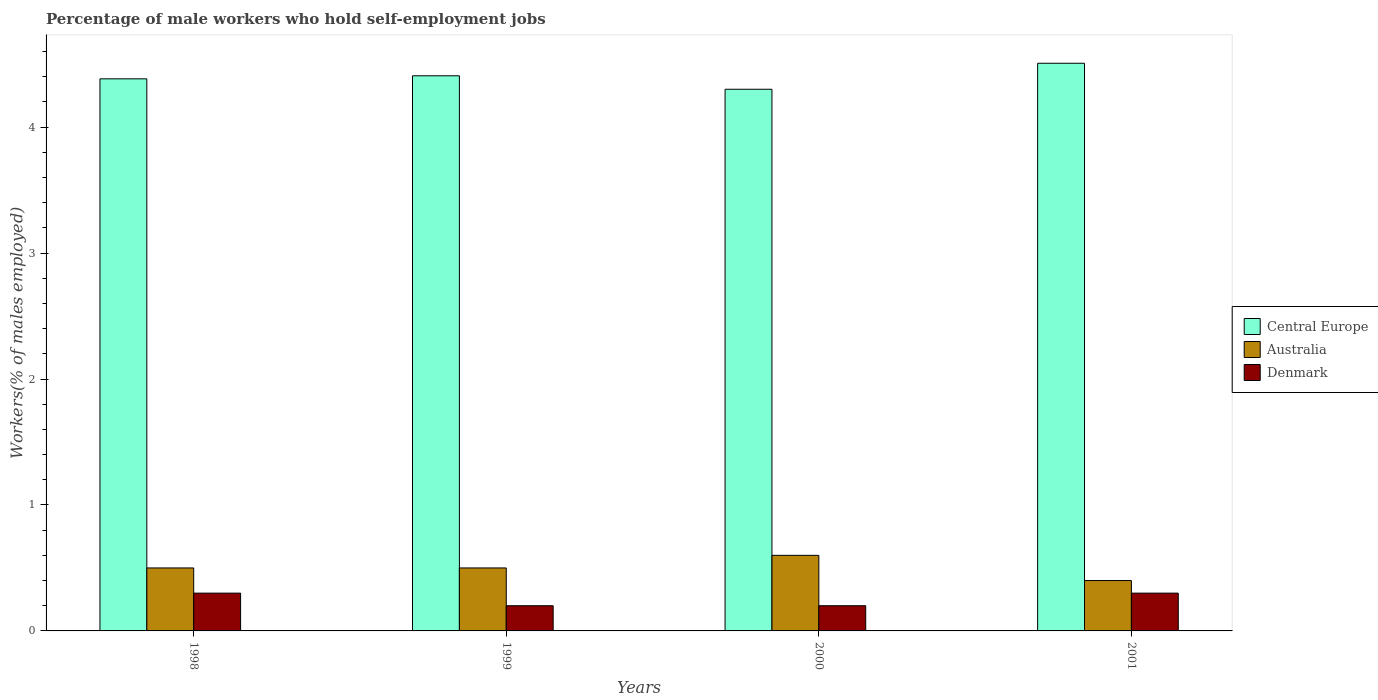How many different coloured bars are there?
Provide a succinct answer. 3. Are the number of bars on each tick of the X-axis equal?
Make the answer very short. Yes. How many bars are there on the 1st tick from the left?
Ensure brevity in your answer.  3. What is the label of the 2nd group of bars from the left?
Make the answer very short. 1999. In how many cases, is the number of bars for a given year not equal to the number of legend labels?
Offer a very short reply. 0. What is the percentage of self-employed male workers in Denmark in 2001?
Offer a terse response. 0.3. Across all years, what is the maximum percentage of self-employed male workers in Denmark?
Your response must be concise. 0.3. Across all years, what is the minimum percentage of self-employed male workers in Australia?
Give a very brief answer. 0.4. In which year was the percentage of self-employed male workers in Denmark maximum?
Keep it short and to the point. 1998. In which year was the percentage of self-employed male workers in Denmark minimum?
Your answer should be compact. 1999. What is the total percentage of self-employed male workers in Denmark in the graph?
Provide a short and direct response. 1. What is the difference between the percentage of self-employed male workers in Central Europe in 1998 and that in 2000?
Make the answer very short. 0.08. What is the difference between the percentage of self-employed male workers in Central Europe in 2000 and the percentage of self-employed male workers in Denmark in 1998?
Give a very brief answer. 4. What is the average percentage of self-employed male workers in Australia per year?
Offer a terse response. 0.5. In the year 1999, what is the difference between the percentage of self-employed male workers in Australia and percentage of self-employed male workers in Central Europe?
Offer a very short reply. -3.91. In how many years, is the percentage of self-employed male workers in Central Europe greater than 3.2 %?
Offer a very short reply. 4. What is the ratio of the percentage of self-employed male workers in Denmark in 2000 to that in 2001?
Make the answer very short. 0.67. Is the difference between the percentage of self-employed male workers in Australia in 1999 and 2000 greater than the difference between the percentage of self-employed male workers in Central Europe in 1999 and 2000?
Ensure brevity in your answer.  No. What is the difference between the highest and the second highest percentage of self-employed male workers in Central Europe?
Your answer should be very brief. 0.1. What is the difference between the highest and the lowest percentage of self-employed male workers in Australia?
Keep it short and to the point. 0.2. What does the 3rd bar from the right in 1998 represents?
Make the answer very short. Central Europe. Are the values on the major ticks of Y-axis written in scientific E-notation?
Keep it short and to the point. No. How many legend labels are there?
Your response must be concise. 3. How are the legend labels stacked?
Your answer should be compact. Vertical. What is the title of the graph?
Provide a succinct answer. Percentage of male workers who hold self-employment jobs. Does "Guinea" appear as one of the legend labels in the graph?
Offer a terse response. No. What is the label or title of the Y-axis?
Ensure brevity in your answer.  Workers(% of males employed). What is the Workers(% of males employed) in Central Europe in 1998?
Offer a terse response. 4.38. What is the Workers(% of males employed) in Australia in 1998?
Give a very brief answer. 0.5. What is the Workers(% of males employed) of Denmark in 1998?
Your answer should be compact. 0.3. What is the Workers(% of males employed) in Central Europe in 1999?
Your response must be concise. 4.41. What is the Workers(% of males employed) in Australia in 1999?
Keep it short and to the point. 0.5. What is the Workers(% of males employed) of Denmark in 1999?
Your answer should be compact. 0.2. What is the Workers(% of males employed) in Central Europe in 2000?
Make the answer very short. 4.3. What is the Workers(% of males employed) in Australia in 2000?
Offer a very short reply. 0.6. What is the Workers(% of males employed) of Denmark in 2000?
Provide a short and direct response. 0.2. What is the Workers(% of males employed) in Central Europe in 2001?
Offer a terse response. 4.51. What is the Workers(% of males employed) of Australia in 2001?
Your answer should be very brief. 0.4. What is the Workers(% of males employed) of Denmark in 2001?
Your answer should be compact. 0.3. Across all years, what is the maximum Workers(% of males employed) in Central Europe?
Ensure brevity in your answer.  4.51. Across all years, what is the maximum Workers(% of males employed) of Australia?
Ensure brevity in your answer.  0.6. Across all years, what is the maximum Workers(% of males employed) of Denmark?
Make the answer very short. 0.3. Across all years, what is the minimum Workers(% of males employed) of Central Europe?
Provide a succinct answer. 4.3. Across all years, what is the minimum Workers(% of males employed) of Australia?
Offer a terse response. 0.4. Across all years, what is the minimum Workers(% of males employed) of Denmark?
Ensure brevity in your answer.  0.2. What is the total Workers(% of males employed) in Central Europe in the graph?
Give a very brief answer. 17.6. What is the total Workers(% of males employed) in Australia in the graph?
Provide a succinct answer. 2. What is the total Workers(% of males employed) in Denmark in the graph?
Ensure brevity in your answer.  1. What is the difference between the Workers(% of males employed) in Central Europe in 1998 and that in 1999?
Make the answer very short. -0.02. What is the difference between the Workers(% of males employed) of Australia in 1998 and that in 1999?
Give a very brief answer. 0. What is the difference between the Workers(% of males employed) of Central Europe in 1998 and that in 2000?
Provide a short and direct response. 0.08. What is the difference between the Workers(% of males employed) in Denmark in 1998 and that in 2000?
Keep it short and to the point. 0.1. What is the difference between the Workers(% of males employed) of Central Europe in 1998 and that in 2001?
Provide a succinct answer. -0.12. What is the difference between the Workers(% of males employed) in Central Europe in 1999 and that in 2000?
Give a very brief answer. 0.11. What is the difference between the Workers(% of males employed) of Australia in 1999 and that in 2000?
Give a very brief answer. -0.1. What is the difference between the Workers(% of males employed) of Central Europe in 1999 and that in 2001?
Your answer should be compact. -0.1. What is the difference between the Workers(% of males employed) in Central Europe in 2000 and that in 2001?
Keep it short and to the point. -0.21. What is the difference between the Workers(% of males employed) in Australia in 2000 and that in 2001?
Make the answer very short. 0.2. What is the difference between the Workers(% of males employed) in Denmark in 2000 and that in 2001?
Make the answer very short. -0.1. What is the difference between the Workers(% of males employed) in Central Europe in 1998 and the Workers(% of males employed) in Australia in 1999?
Your answer should be compact. 3.88. What is the difference between the Workers(% of males employed) in Central Europe in 1998 and the Workers(% of males employed) in Denmark in 1999?
Your answer should be very brief. 4.18. What is the difference between the Workers(% of males employed) of Central Europe in 1998 and the Workers(% of males employed) of Australia in 2000?
Your answer should be compact. 3.78. What is the difference between the Workers(% of males employed) of Central Europe in 1998 and the Workers(% of males employed) of Denmark in 2000?
Make the answer very short. 4.18. What is the difference between the Workers(% of males employed) in Australia in 1998 and the Workers(% of males employed) in Denmark in 2000?
Give a very brief answer. 0.3. What is the difference between the Workers(% of males employed) of Central Europe in 1998 and the Workers(% of males employed) of Australia in 2001?
Make the answer very short. 3.98. What is the difference between the Workers(% of males employed) of Central Europe in 1998 and the Workers(% of males employed) of Denmark in 2001?
Give a very brief answer. 4.08. What is the difference between the Workers(% of males employed) in Australia in 1998 and the Workers(% of males employed) in Denmark in 2001?
Offer a very short reply. 0.2. What is the difference between the Workers(% of males employed) in Central Europe in 1999 and the Workers(% of males employed) in Australia in 2000?
Ensure brevity in your answer.  3.81. What is the difference between the Workers(% of males employed) of Central Europe in 1999 and the Workers(% of males employed) of Denmark in 2000?
Ensure brevity in your answer.  4.21. What is the difference between the Workers(% of males employed) of Central Europe in 1999 and the Workers(% of males employed) of Australia in 2001?
Keep it short and to the point. 4.01. What is the difference between the Workers(% of males employed) in Central Europe in 1999 and the Workers(% of males employed) in Denmark in 2001?
Your answer should be very brief. 4.11. What is the difference between the Workers(% of males employed) of Australia in 1999 and the Workers(% of males employed) of Denmark in 2001?
Your answer should be compact. 0.2. What is the difference between the Workers(% of males employed) of Central Europe in 2000 and the Workers(% of males employed) of Australia in 2001?
Provide a succinct answer. 3.9. What is the difference between the Workers(% of males employed) of Central Europe in 2000 and the Workers(% of males employed) of Denmark in 2001?
Give a very brief answer. 4. What is the average Workers(% of males employed) in Central Europe per year?
Offer a very short reply. 4.4. In the year 1998, what is the difference between the Workers(% of males employed) in Central Europe and Workers(% of males employed) in Australia?
Your response must be concise. 3.88. In the year 1998, what is the difference between the Workers(% of males employed) in Central Europe and Workers(% of males employed) in Denmark?
Offer a very short reply. 4.08. In the year 1999, what is the difference between the Workers(% of males employed) of Central Europe and Workers(% of males employed) of Australia?
Keep it short and to the point. 3.91. In the year 1999, what is the difference between the Workers(% of males employed) of Central Europe and Workers(% of males employed) of Denmark?
Your answer should be compact. 4.21. In the year 2000, what is the difference between the Workers(% of males employed) of Central Europe and Workers(% of males employed) of Australia?
Provide a short and direct response. 3.7. In the year 2000, what is the difference between the Workers(% of males employed) in Central Europe and Workers(% of males employed) in Denmark?
Your response must be concise. 4.1. In the year 2000, what is the difference between the Workers(% of males employed) of Australia and Workers(% of males employed) of Denmark?
Give a very brief answer. 0.4. In the year 2001, what is the difference between the Workers(% of males employed) in Central Europe and Workers(% of males employed) in Australia?
Your answer should be very brief. 4.11. In the year 2001, what is the difference between the Workers(% of males employed) of Central Europe and Workers(% of males employed) of Denmark?
Provide a short and direct response. 4.21. In the year 2001, what is the difference between the Workers(% of males employed) of Australia and Workers(% of males employed) of Denmark?
Keep it short and to the point. 0.1. What is the ratio of the Workers(% of males employed) in Central Europe in 1998 to that in 2000?
Ensure brevity in your answer.  1.02. What is the ratio of the Workers(% of males employed) in Australia in 1998 to that in 2000?
Your response must be concise. 0.83. What is the ratio of the Workers(% of males employed) of Denmark in 1998 to that in 2000?
Make the answer very short. 1.5. What is the ratio of the Workers(% of males employed) of Central Europe in 1998 to that in 2001?
Make the answer very short. 0.97. What is the ratio of the Workers(% of males employed) of Central Europe in 1999 to that in 2000?
Your response must be concise. 1.02. What is the ratio of the Workers(% of males employed) of Australia in 1999 to that in 2000?
Offer a very short reply. 0.83. What is the ratio of the Workers(% of males employed) in Denmark in 1999 to that in 2000?
Provide a short and direct response. 1. What is the ratio of the Workers(% of males employed) in Central Europe in 1999 to that in 2001?
Offer a very short reply. 0.98. What is the ratio of the Workers(% of males employed) in Denmark in 1999 to that in 2001?
Provide a succinct answer. 0.67. What is the ratio of the Workers(% of males employed) of Central Europe in 2000 to that in 2001?
Your answer should be compact. 0.95. What is the difference between the highest and the second highest Workers(% of males employed) in Central Europe?
Your response must be concise. 0.1. What is the difference between the highest and the second highest Workers(% of males employed) in Australia?
Provide a succinct answer. 0.1. What is the difference between the highest and the second highest Workers(% of males employed) in Denmark?
Offer a very short reply. 0. What is the difference between the highest and the lowest Workers(% of males employed) of Central Europe?
Your response must be concise. 0.21. 